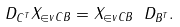<formula> <loc_0><loc_0><loc_500><loc_500>\ D _ { C ^ { T } } X _ { \in v { C } B } = X _ { \in v { C } B } \ D _ { B ^ { T } } .</formula> 